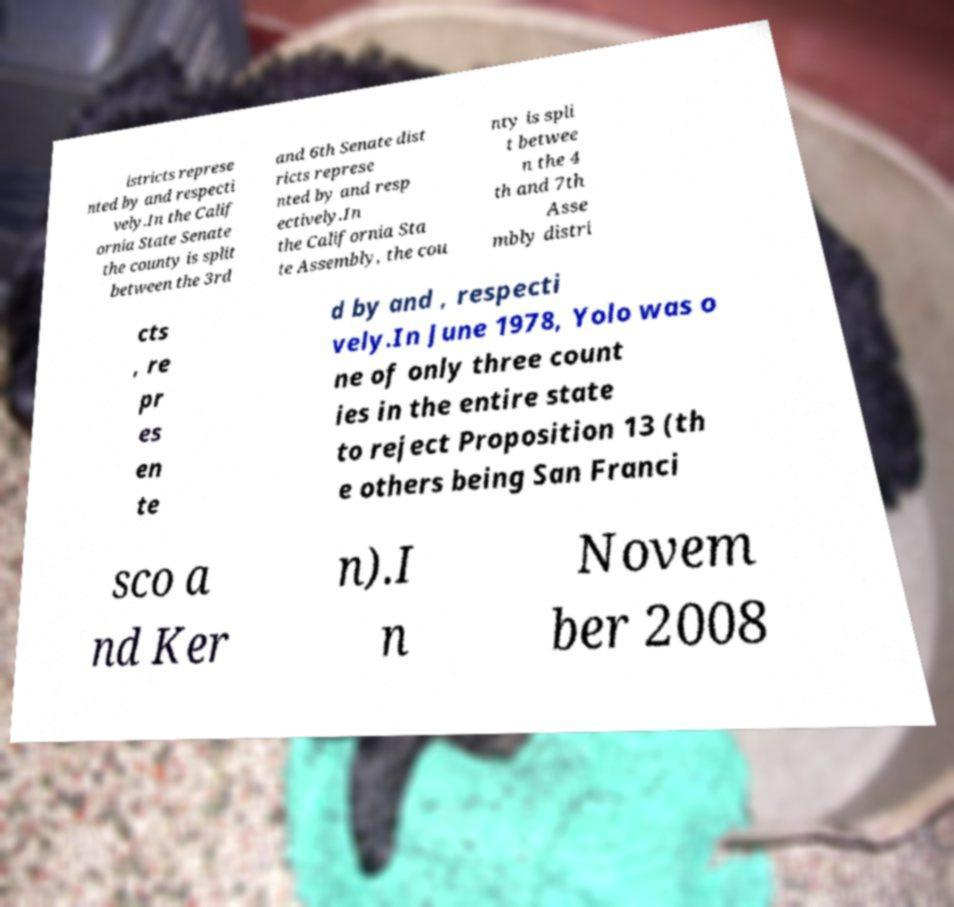I need the written content from this picture converted into text. Can you do that? istricts represe nted by and respecti vely.In the Calif ornia State Senate the county is split between the 3rd and 6th Senate dist ricts represe nted by and resp ectively.In the California Sta te Assembly, the cou nty is spli t betwee n the 4 th and 7th Asse mbly distri cts , re pr es en te d by and , respecti vely.In June 1978, Yolo was o ne of only three count ies in the entire state to reject Proposition 13 (th e others being San Franci sco a nd Ker n).I n Novem ber 2008 